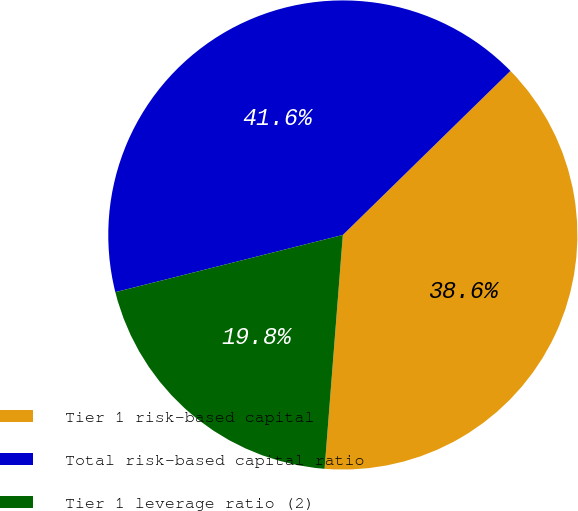Convert chart to OTSL. <chart><loc_0><loc_0><loc_500><loc_500><pie_chart><fcel>Tier 1 risk-based capital<fcel>Total risk-based capital ratio<fcel>Tier 1 leverage ratio (2)<nl><fcel>38.57%<fcel>41.59%<fcel>19.84%<nl></chart> 